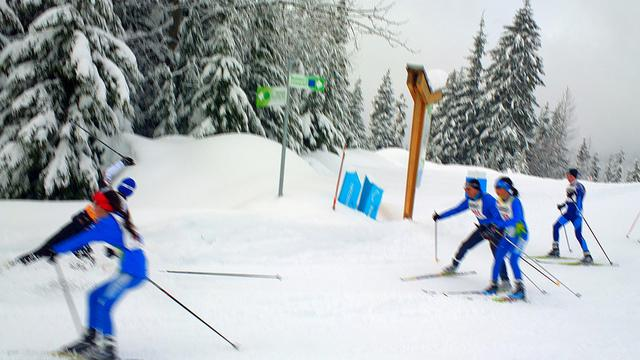What are these people doing with each other? Please explain your reasoning. racing. They are in a competition. 